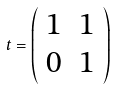Convert formula to latex. <formula><loc_0><loc_0><loc_500><loc_500>t = \left ( \begin{array} { c c } { 1 } & { 1 } \\ { 0 } & { 1 } \end{array} \right )</formula> 